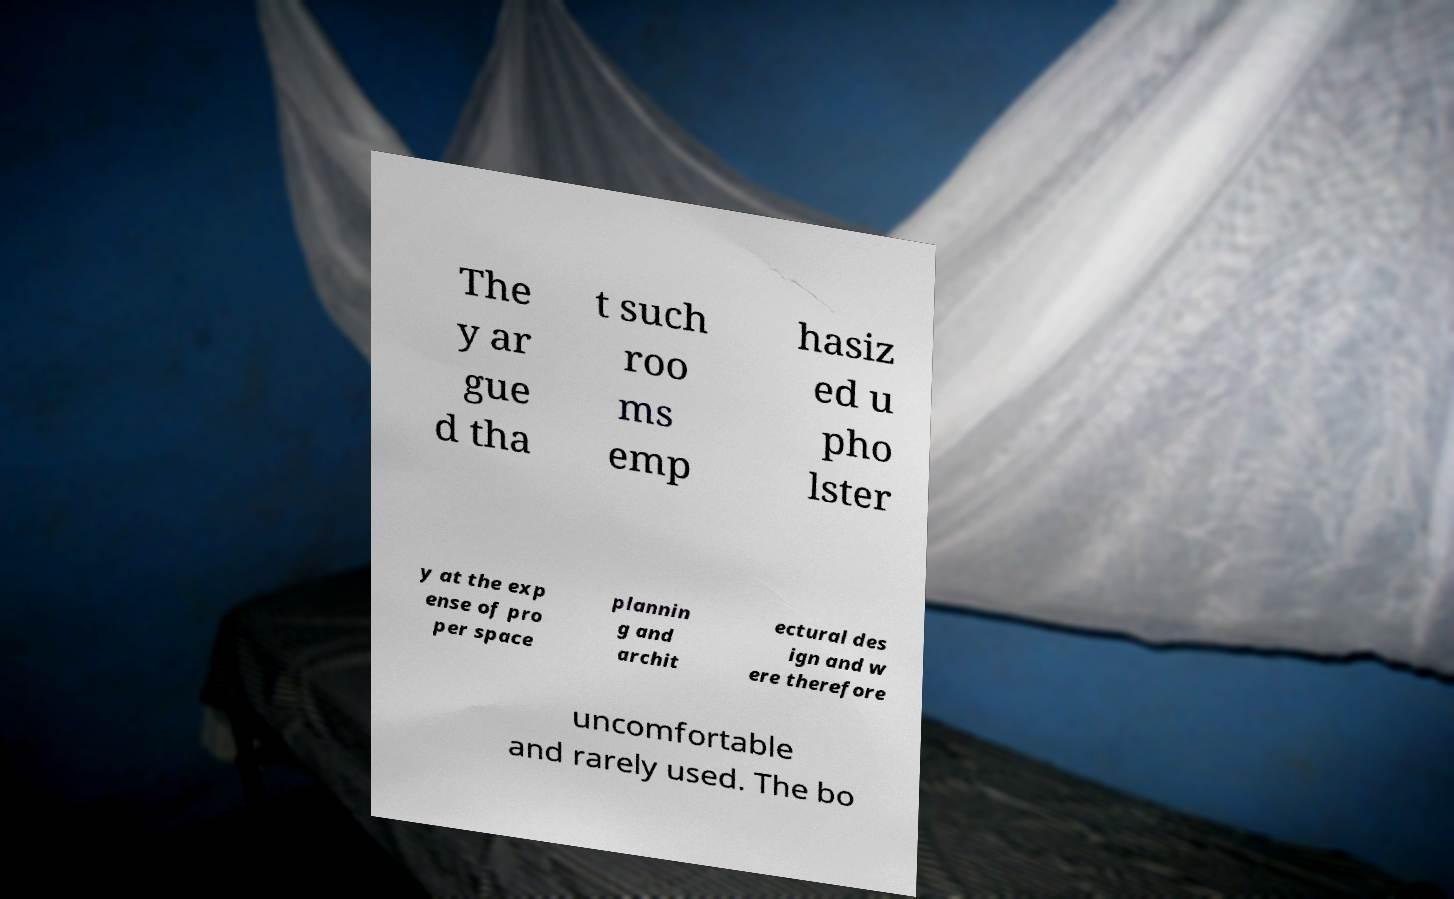Please read and relay the text visible in this image. What does it say? The y ar gue d tha t such roo ms emp hasiz ed u pho lster y at the exp ense of pro per space plannin g and archit ectural des ign and w ere therefore uncomfortable and rarely used. The bo 